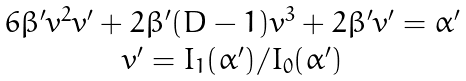<formula> <loc_0><loc_0><loc_500><loc_500>\begin{array} { c } 6 \beta ^ { \prime } v ^ { 2 } v ^ { \prime } + 2 \beta ^ { \prime } ( D - 1 ) v ^ { 3 } + 2 \beta ^ { \prime } v ^ { \prime } = \alpha ^ { \prime } \\ v ^ { \prime } = I _ { 1 } ( \alpha ^ { \prime } ) / I _ { 0 } ( \alpha ^ { \prime } ) \end{array}</formula> 